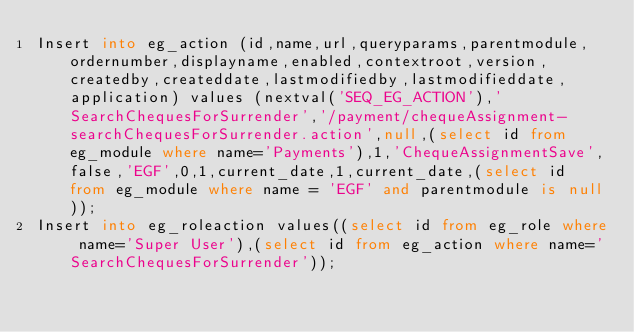Convert code to text. <code><loc_0><loc_0><loc_500><loc_500><_SQL_>Insert into eg_action (id,name,url,queryparams,parentmodule,ordernumber,displayname,enabled,contextroot,version,createdby,createddate,lastmodifiedby,lastmodifieddate,application) values (nextval('SEQ_EG_ACTION'),'SearchChequesForSurrender','/payment/chequeAssignment-searchChequesForSurrender.action',null,(select id from eg_module where name='Payments'),1,'ChequeAssignmentSave',false,'EGF',0,1,current_date,1,current_date,(select id from eg_module where name = 'EGF' and parentmodule is null));
Insert into eg_roleaction values((select id from eg_role where name='Super User'),(select id from eg_action where name='SearchChequesForSurrender'));

</code> 